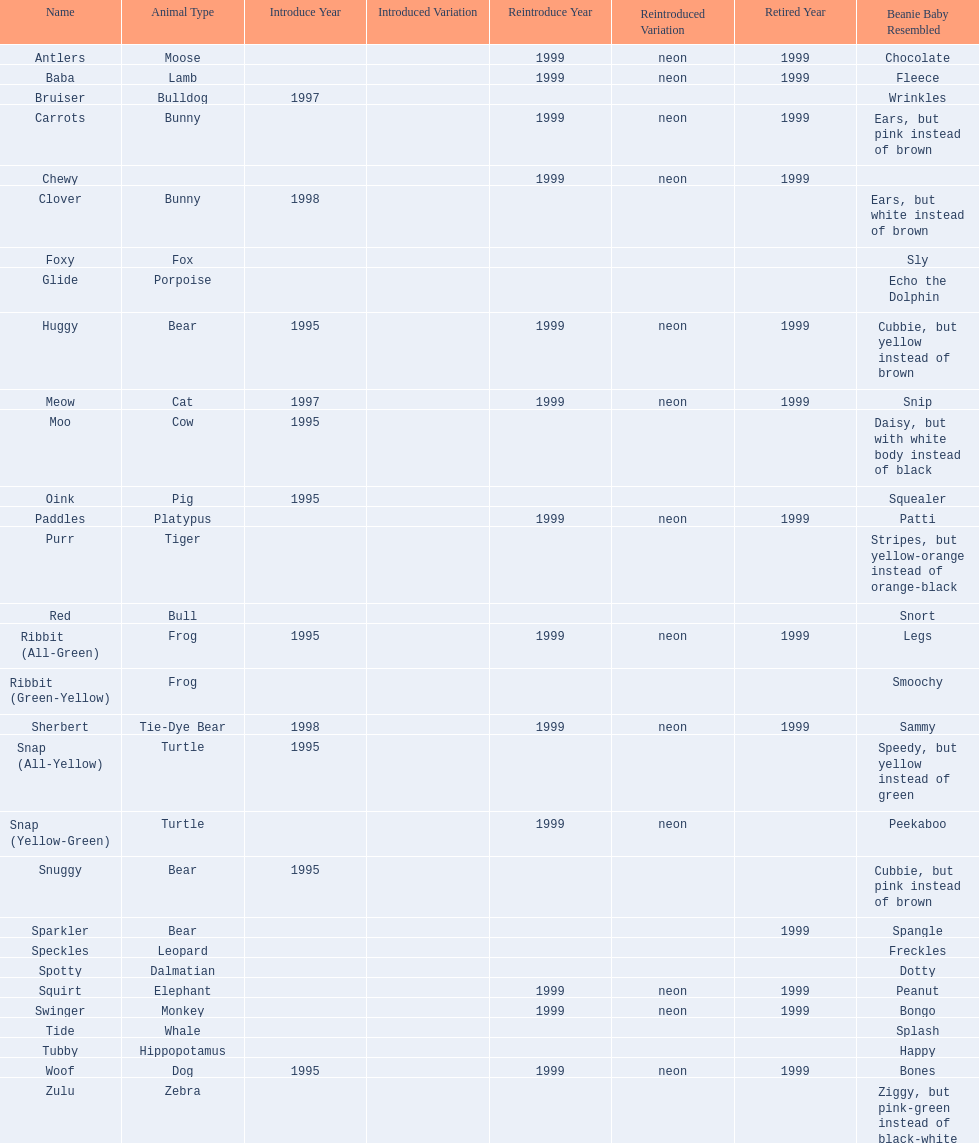What are all the different names of the pillow pals? Antlers, Baba, Bruiser, Carrots, Chewy, Clover, Foxy, Glide, Huggy, Meow, Moo, Oink, Paddles, Purr, Red, Ribbit (All-Green), Ribbit (Green-Yellow), Sherbert, Snap (All-Yellow), Snap (Yellow-Green), Snuggy, Sparkler, Speckles, Spotty, Squirt, Swinger, Tide, Tubby, Woof, Zulu. Which of these are a dalmatian? Spotty. 